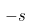Convert formula to latex. <formula><loc_0><loc_0><loc_500><loc_500>- s</formula> 